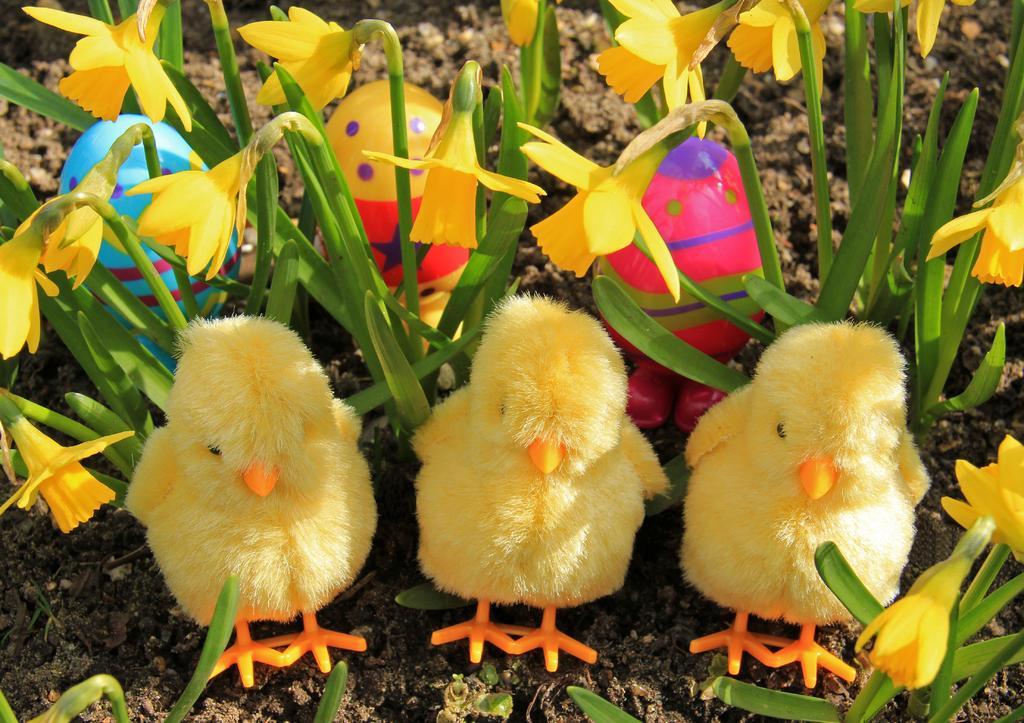Can you describe this image briefly? In front of the picture, we see three hot chicks which are in yellow color. Behind that, we see grass and flowers. These flowers are in yellow color. Behind that, we see the toys in pink, yellow and blue color. In the background, we see the soil. 